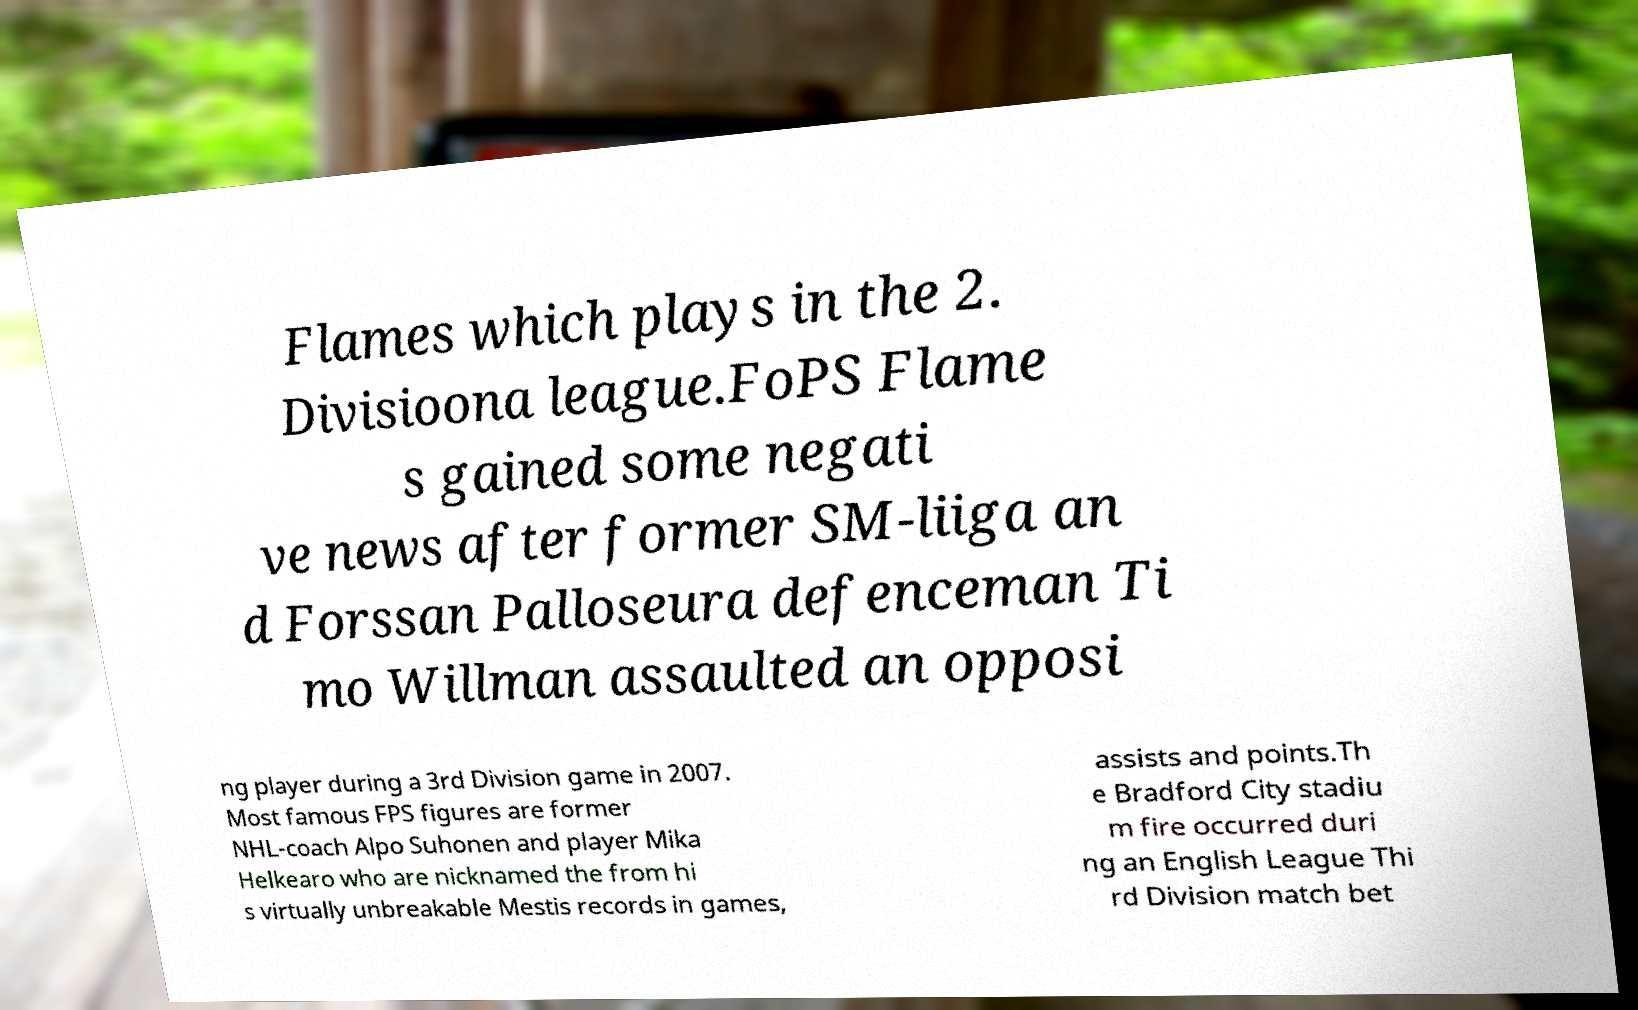For documentation purposes, I need the text within this image transcribed. Could you provide that? Flames which plays in the 2. Divisioona league.FoPS Flame s gained some negati ve news after former SM-liiga an d Forssan Palloseura defenceman Ti mo Willman assaulted an opposi ng player during a 3rd Division game in 2007. Most famous FPS figures are former NHL-coach Alpo Suhonen and player Mika Helkearo who are nicknamed the from hi s virtually unbreakable Mestis records in games, assists and points.Th e Bradford City stadiu m fire occurred duri ng an English League Thi rd Division match bet 